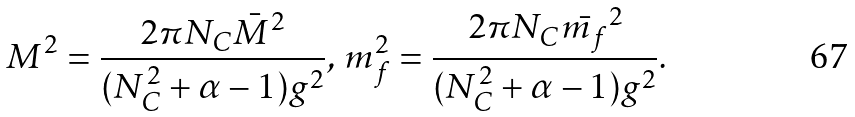Convert formula to latex. <formula><loc_0><loc_0><loc_500><loc_500>M ^ { 2 } = \frac { 2 \pi N _ { C } \bar { M } ^ { 2 } } { ( N _ { C } ^ { 2 } + \alpha - 1 ) g ^ { 2 } } , \, m _ { f } ^ { 2 } = \frac { 2 \pi N _ { C } \bar { m _ { f } } ^ { 2 } } { ( N _ { C } ^ { 2 } + \alpha - 1 ) g ^ { 2 } } .</formula> 